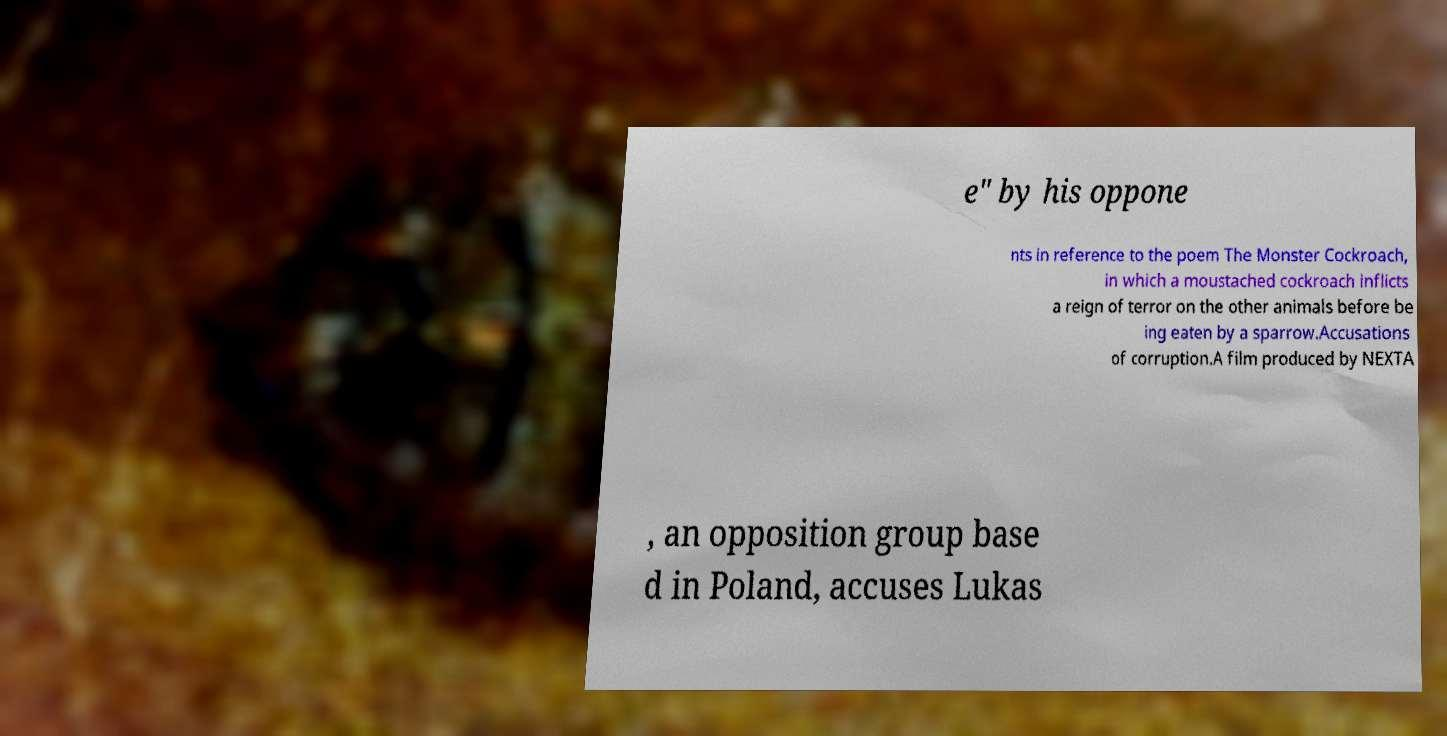Please identify and transcribe the text found in this image. e" by his oppone nts in reference to the poem The Monster Cockroach, in which a moustached cockroach inflicts a reign of terror on the other animals before be ing eaten by a sparrow.Accusations of corruption.A film produced by NEXTA , an opposition group base d in Poland, accuses Lukas 